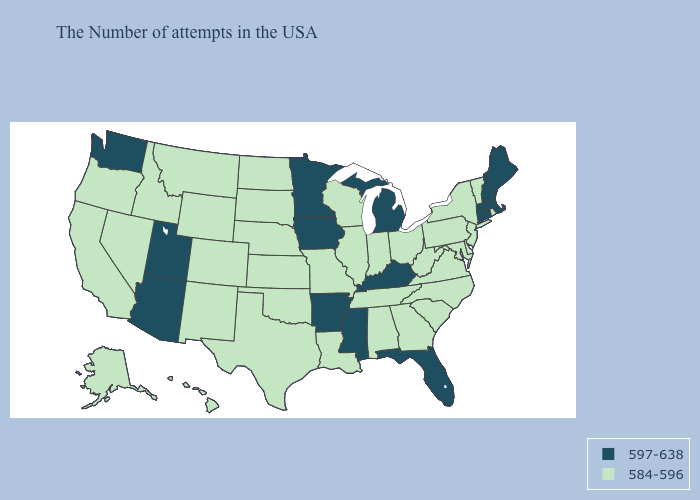What is the value of Illinois?
Keep it brief. 584-596. Does Iowa have the lowest value in the MidWest?
Short answer required. No. What is the value of Tennessee?
Concise answer only. 584-596. What is the highest value in the South ?
Short answer required. 597-638. What is the lowest value in states that border Oklahoma?
Write a very short answer. 584-596. Name the states that have a value in the range 584-596?
Short answer required. Rhode Island, Vermont, New York, New Jersey, Delaware, Maryland, Pennsylvania, Virginia, North Carolina, South Carolina, West Virginia, Ohio, Georgia, Indiana, Alabama, Tennessee, Wisconsin, Illinois, Louisiana, Missouri, Kansas, Nebraska, Oklahoma, Texas, South Dakota, North Dakota, Wyoming, Colorado, New Mexico, Montana, Idaho, Nevada, California, Oregon, Alaska, Hawaii. What is the value of Kentucky?
Be succinct. 597-638. What is the highest value in the West ?
Concise answer only. 597-638. What is the value of Alabama?
Give a very brief answer. 584-596. Does Illinois have the highest value in the MidWest?
Give a very brief answer. No. Name the states that have a value in the range 584-596?
Short answer required. Rhode Island, Vermont, New York, New Jersey, Delaware, Maryland, Pennsylvania, Virginia, North Carolina, South Carolina, West Virginia, Ohio, Georgia, Indiana, Alabama, Tennessee, Wisconsin, Illinois, Louisiana, Missouri, Kansas, Nebraska, Oklahoma, Texas, South Dakota, North Dakota, Wyoming, Colorado, New Mexico, Montana, Idaho, Nevada, California, Oregon, Alaska, Hawaii. Which states have the lowest value in the West?
Answer briefly. Wyoming, Colorado, New Mexico, Montana, Idaho, Nevada, California, Oregon, Alaska, Hawaii. Which states have the lowest value in the USA?
Quick response, please. Rhode Island, Vermont, New York, New Jersey, Delaware, Maryland, Pennsylvania, Virginia, North Carolina, South Carolina, West Virginia, Ohio, Georgia, Indiana, Alabama, Tennessee, Wisconsin, Illinois, Louisiana, Missouri, Kansas, Nebraska, Oklahoma, Texas, South Dakota, North Dakota, Wyoming, Colorado, New Mexico, Montana, Idaho, Nevada, California, Oregon, Alaska, Hawaii. What is the value of South Dakota?
Short answer required. 584-596. What is the value of West Virginia?
Concise answer only. 584-596. 